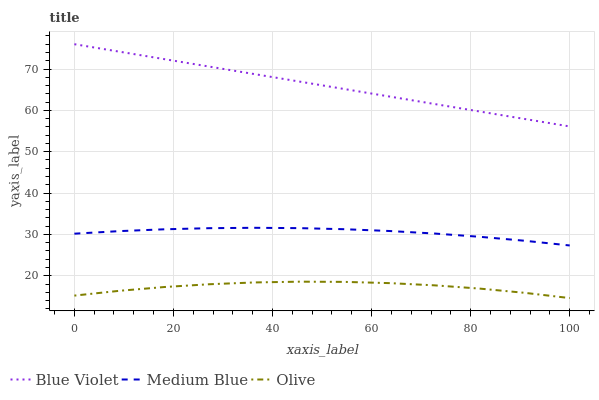Does Olive have the minimum area under the curve?
Answer yes or no. Yes. Does Blue Violet have the maximum area under the curve?
Answer yes or no. Yes. Does Medium Blue have the minimum area under the curve?
Answer yes or no. No. Does Medium Blue have the maximum area under the curve?
Answer yes or no. No. Is Blue Violet the smoothest?
Answer yes or no. Yes. Is Olive the roughest?
Answer yes or no. Yes. Is Medium Blue the smoothest?
Answer yes or no. No. Is Medium Blue the roughest?
Answer yes or no. No. Does Medium Blue have the lowest value?
Answer yes or no. No. Does Blue Violet have the highest value?
Answer yes or no. Yes. Does Medium Blue have the highest value?
Answer yes or no. No. Is Medium Blue less than Blue Violet?
Answer yes or no. Yes. Is Medium Blue greater than Olive?
Answer yes or no. Yes. Does Medium Blue intersect Blue Violet?
Answer yes or no. No. 